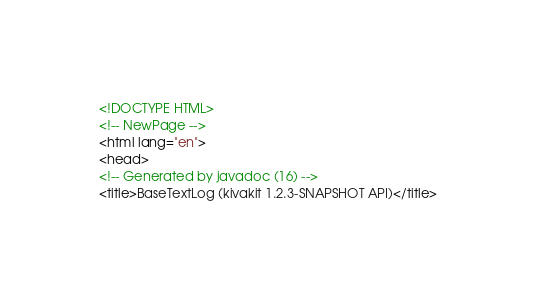<code> <loc_0><loc_0><loc_500><loc_500><_HTML_><!DOCTYPE HTML>
<!-- NewPage -->
<html lang="en">
<head>
<!-- Generated by javadoc (16) -->
<title>BaseTextLog (kivakit 1.2.3-SNAPSHOT API)</title></code> 